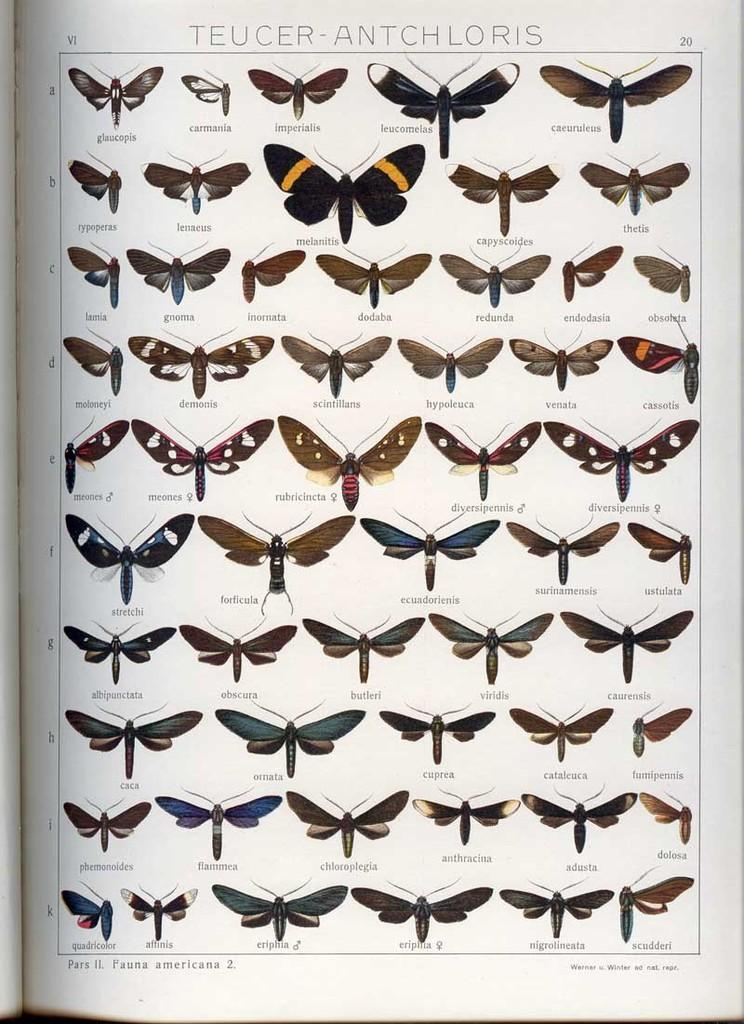What is the main object in the image? There is a book in the image. What can be found on a specific page of the book? The page has many images of butterflies and dragonflies. Is there any text on the page? Yes, there is text on the page. What type of fight is taking place between the butterflies and dragonflies on the page? There is no fight taking place between the butterflies and dragonflies on the page; they are simply depicted in images. What tools might a carpenter use to create a coil in the image? There is no carpenter or coil present in the image; it features a page with images of butterflies and dragonflies and accompanying text. 